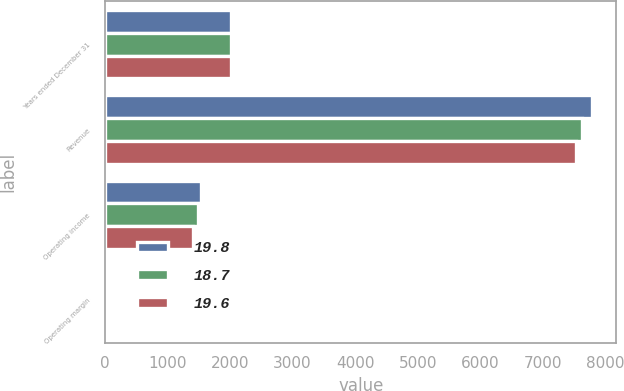<chart> <loc_0><loc_0><loc_500><loc_500><stacked_bar_chart><ecel><fcel>Years ended December 31<fcel>Revenue<fcel>Operating income<fcel>Operating margin<nl><fcel>19.8<fcel>2013<fcel>7789<fcel>1540<fcel>19.8<nl><fcel>18.7<fcel>2012<fcel>7632<fcel>1493<fcel>19.6<nl><fcel>19.6<fcel>2011<fcel>7537<fcel>1413<fcel>18.7<nl></chart> 